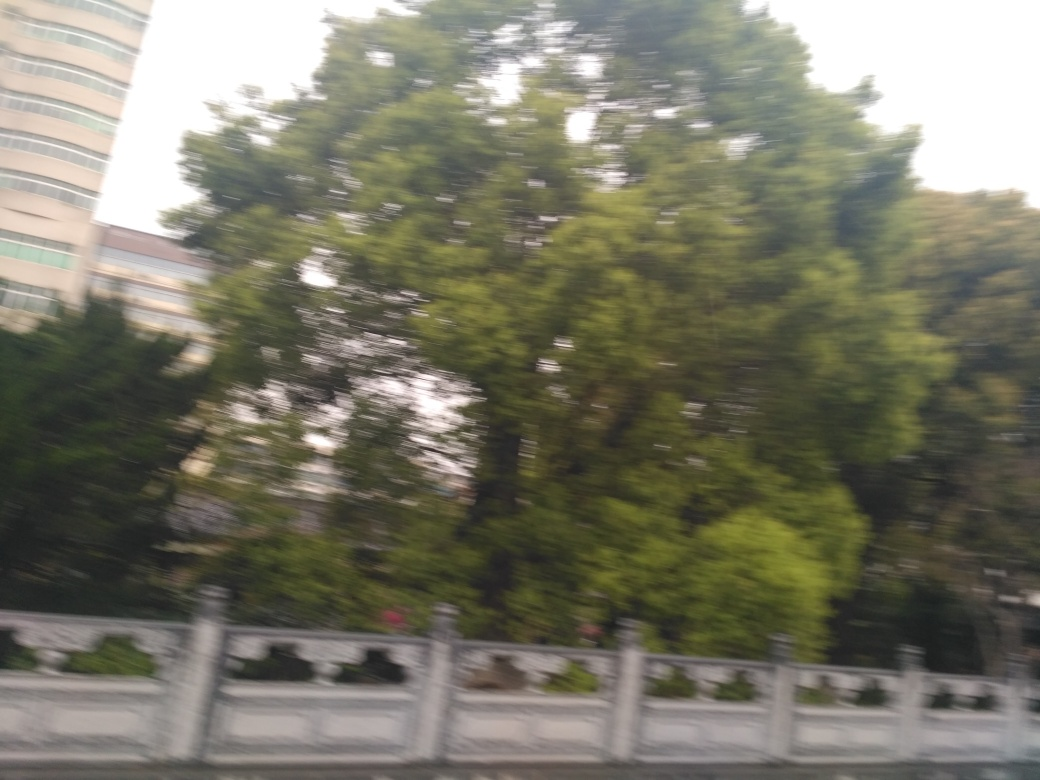Can you describe the atmosphere or mood conveyed by the image? The image exudes a certain dynamism and haste, likely due to the motion blur which suggests it was taken from a moving vehicle. The verdant greenery hints at a serene, natural setting possibly within an urban environment, offering a fleeting moment of tranquility amidst the hustle and bustle of city life. 